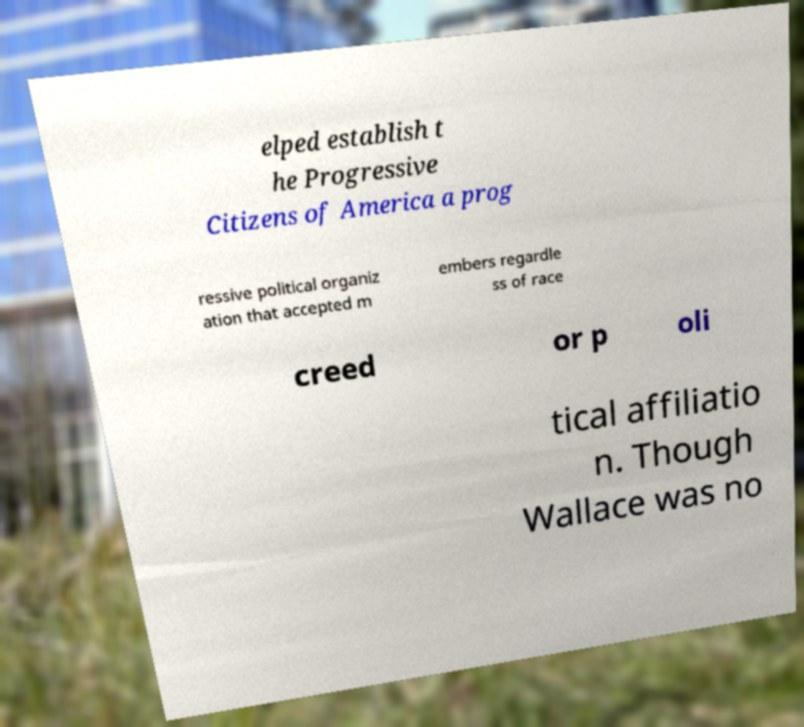I need the written content from this picture converted into text. Can you do that? elped establish t he Progressive Citizens of America a prog ressive political organiz ation that accepted m embers regardle ss of race creed or p oli tical affiliatio n. Though Wallace was no 